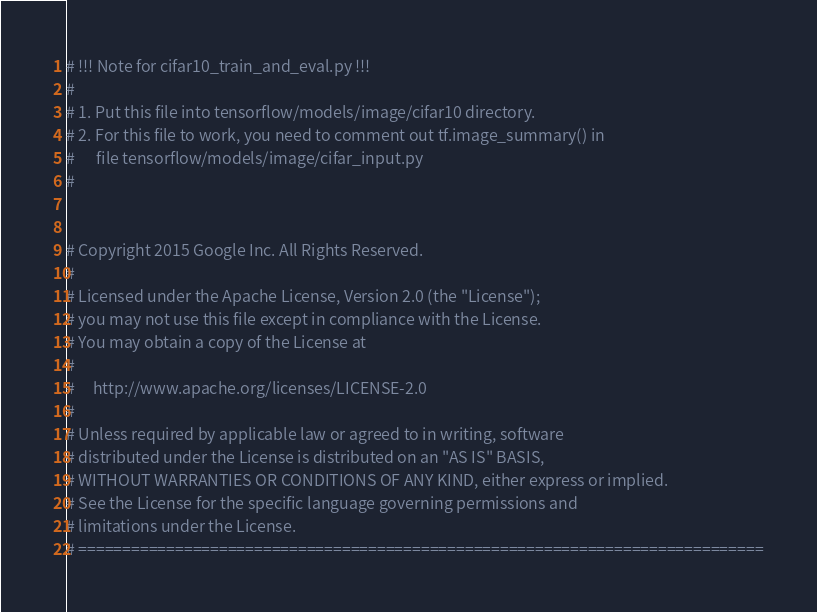<code> <loc_0><loc_0><loc_500><loc_500><_Python_># !!! Note for cifar10_train_and_eval.py !!!
#
# 1. Put this file into tensorflow/models/image/cifar10 directory.
# 2. For this file to work, you need to comment out tf.image_summary() in
#      file tensorflow/models/image/cifar_input.py
#


# Copyright 2015 Google Inc. All Rights Reserved.
#
# Licensed under the Apache License, Version 2.0 (the "License");
# you may not use this file except in compliance with the License.
# You may obtain a copy of the License at
#
#     http://www.apache.org/licenses/LICENSE-2.0
#
# Unless required by applicable law or agreed to in writing, software
# distributed under the License is distributed on an "AS IS" BASIS,
# WITHOUT WARRANTIES OR CONDITIONS OF ANY KIND, either express or implied.
# See the License for the specific language governing permissions and
# limitations under the License.
# ==============================================================================
</code> 